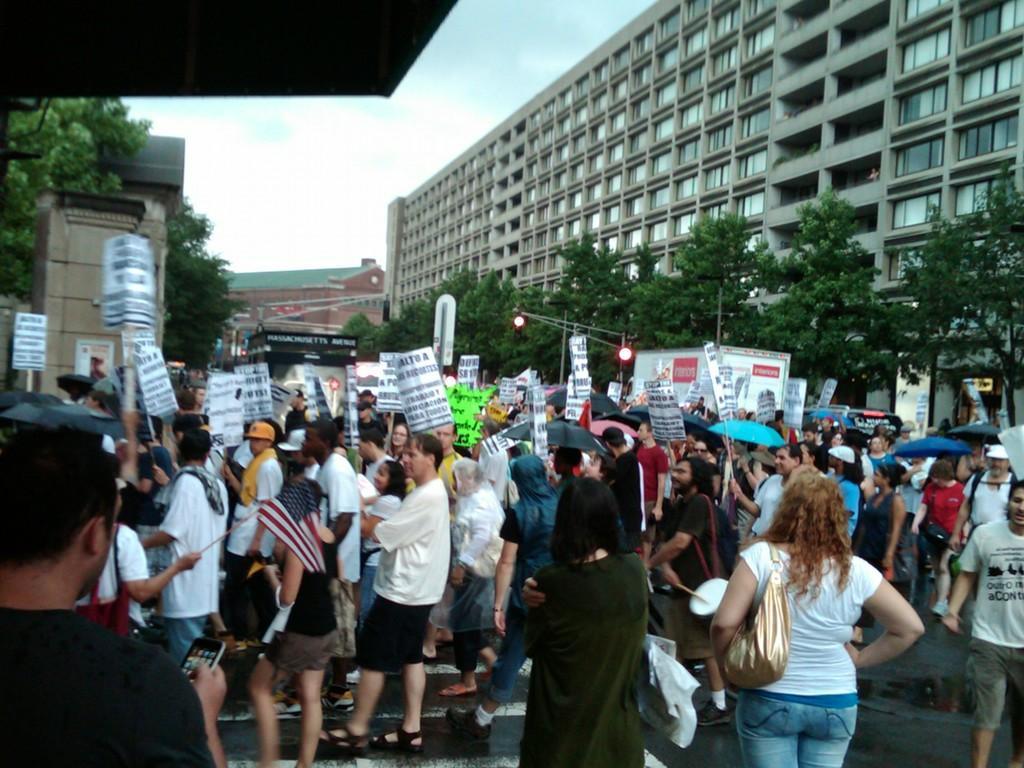In one or two sentences, can you explain what this image depicts? In this image we can see a few people, among them some are holding the objects, there are buildings, trees, light and poles, in the background, we can see the sky with clouds. 